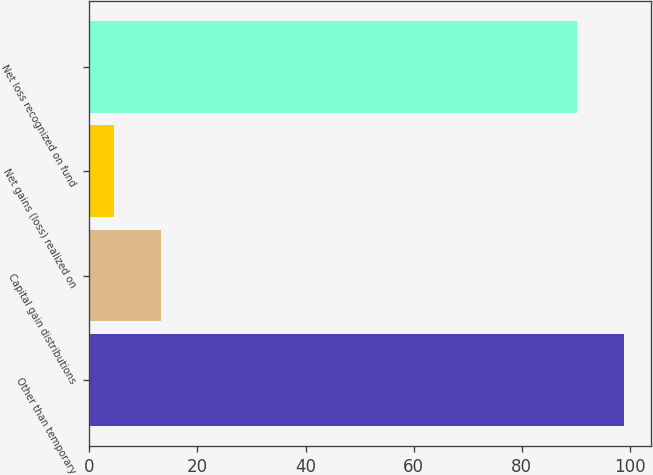Convert chart. <chart><loc_0><loc_0><loc_500><loc_500><bar_chart><fcel>Other than temporary<fcel>Capital gain distributions<fcel>Net gains (loss) realized on<fcel>Net loss recognized on fund<nl><fcel>98.88<fcel>13.18<fcel>4.5<fcel>90.2<nl></chart> 